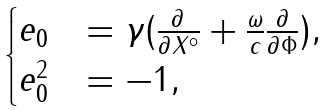Convert formula to latex. <formula><loc_0><loc_0><loc_500><loc_500>\begin{cases} e _ { 0 } & = \gamma ( \frac { \partial } { \partial X ^ { \circ } } + \frac { \omega } { c } \frac { \partial } { \partial \Phi } ) , \\ e _ { 0 } ^ { 2 } & = - 1 , \\ \end{cases}</formula> 